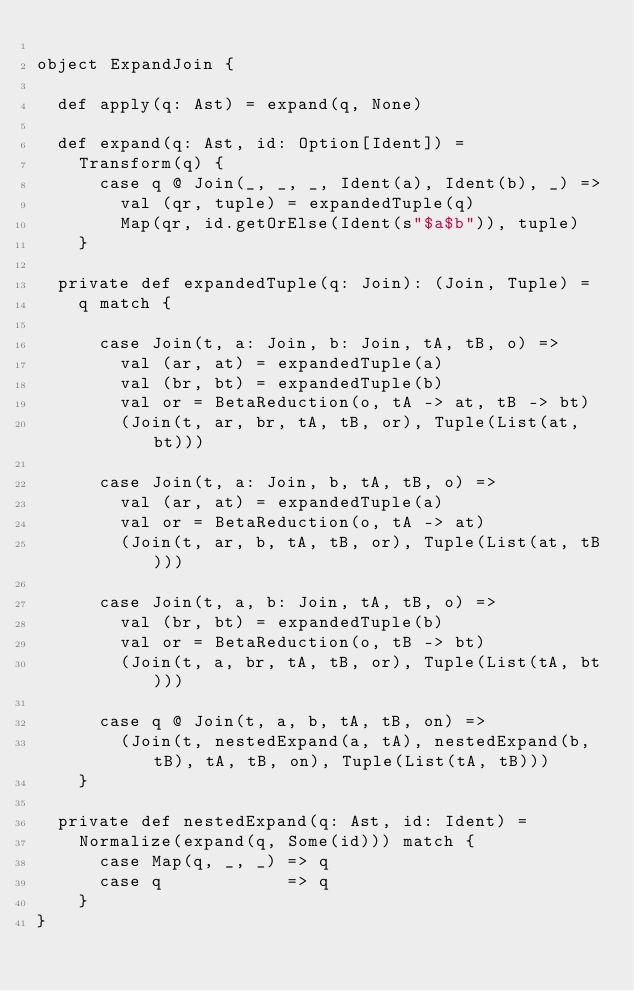Convert code to text. <code><loc_0><loc_0><loc_500><loc_500><_Scala_>
object ExpandJoin {

  def apply(q: Ast) = expand(q, None)

  def expand(q: Ast, id: Option[Ident]) =
    Transform(q) {
      case q @ Join(_, _, _, Ident(a), Ident(b), _) =>
        val (qr, tuple) = expandedTuple(q)
        Map(qr, id.getOrElse(Ident(s"$a$b")), tuple)
    }

  private def expandedTuple(q: Join): (Join, Tuple) =
    q match {

      case Join(t, a: Join, b: Join, tA, tB, o) =>
        val (ar, at) = expandedTuple(a)
        val (br, bt) = expandedTuple(b)
        val or = BetaReduction(o, tA -> at, tB -> bt)
        (Join(t, ar, br, tA, tB, or), Tuple(List(at, bt)))

      case Join(t, a: Join, b, tA, tB, o) =>
        val (ar, at) = expandedTuple(a)
        val or = BetaReduction(o, tA -> at)
        (Join(t, ar, b, tA, tB, or), Tuple(List(at, tB)))

      case Join(t, a, b: Join, tA, tB, o) =>
        val (br, bt) = expandedTuple(b)
        val or = BetaReduction(o, tB -> bt)
        (Join(t, a, br, tA, tB, or), Tuple(List(tA, bt)))

      case q @ Join(t, a, b, tA, tB, on) =>
        (Join(t, nestedExpand(a, tA), nestedExpand(b, tB), tA, tB, on), Tuple(List(tA, tB)))
    }

  private def nestedExpand(q: Ast, id: Ident) =
    Normalize(expand(q, Some(id))) match {
      case Map(q, _, _) => q
      case q            => q
    }
}</code> 